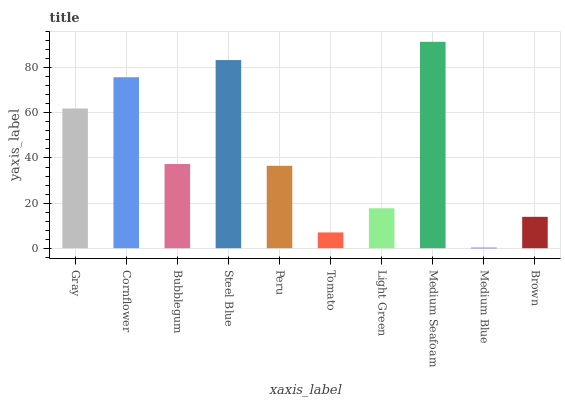Is Medium Blue the minimum?
Answer yes or no. Yes. Is Medium Seafoam the maximum?
Answer yes or no. Yes. Is Cornflower the minimum?
Answer yes or no. No. Is Cornflower the maximum?
Answer yes or no. No. Is Cornflower greater than Gray?
Answer yes or no. Yes. Is Gray less than Cornflower?
Answer yes or no. Yes. Is Gray greater than Cornflower?
Answer yes or no. No. Is Cornflower less than Gray?
Answer yes or no. No. Is Bubblegum the high median?
Answer yes or no. Yes. Is Peru the low median?
Answer yes or no. Yes. Is Medium Seafoam the high median?
Answer yes or no. No. Is Light Green the low median?
Answer yes or no. No. 